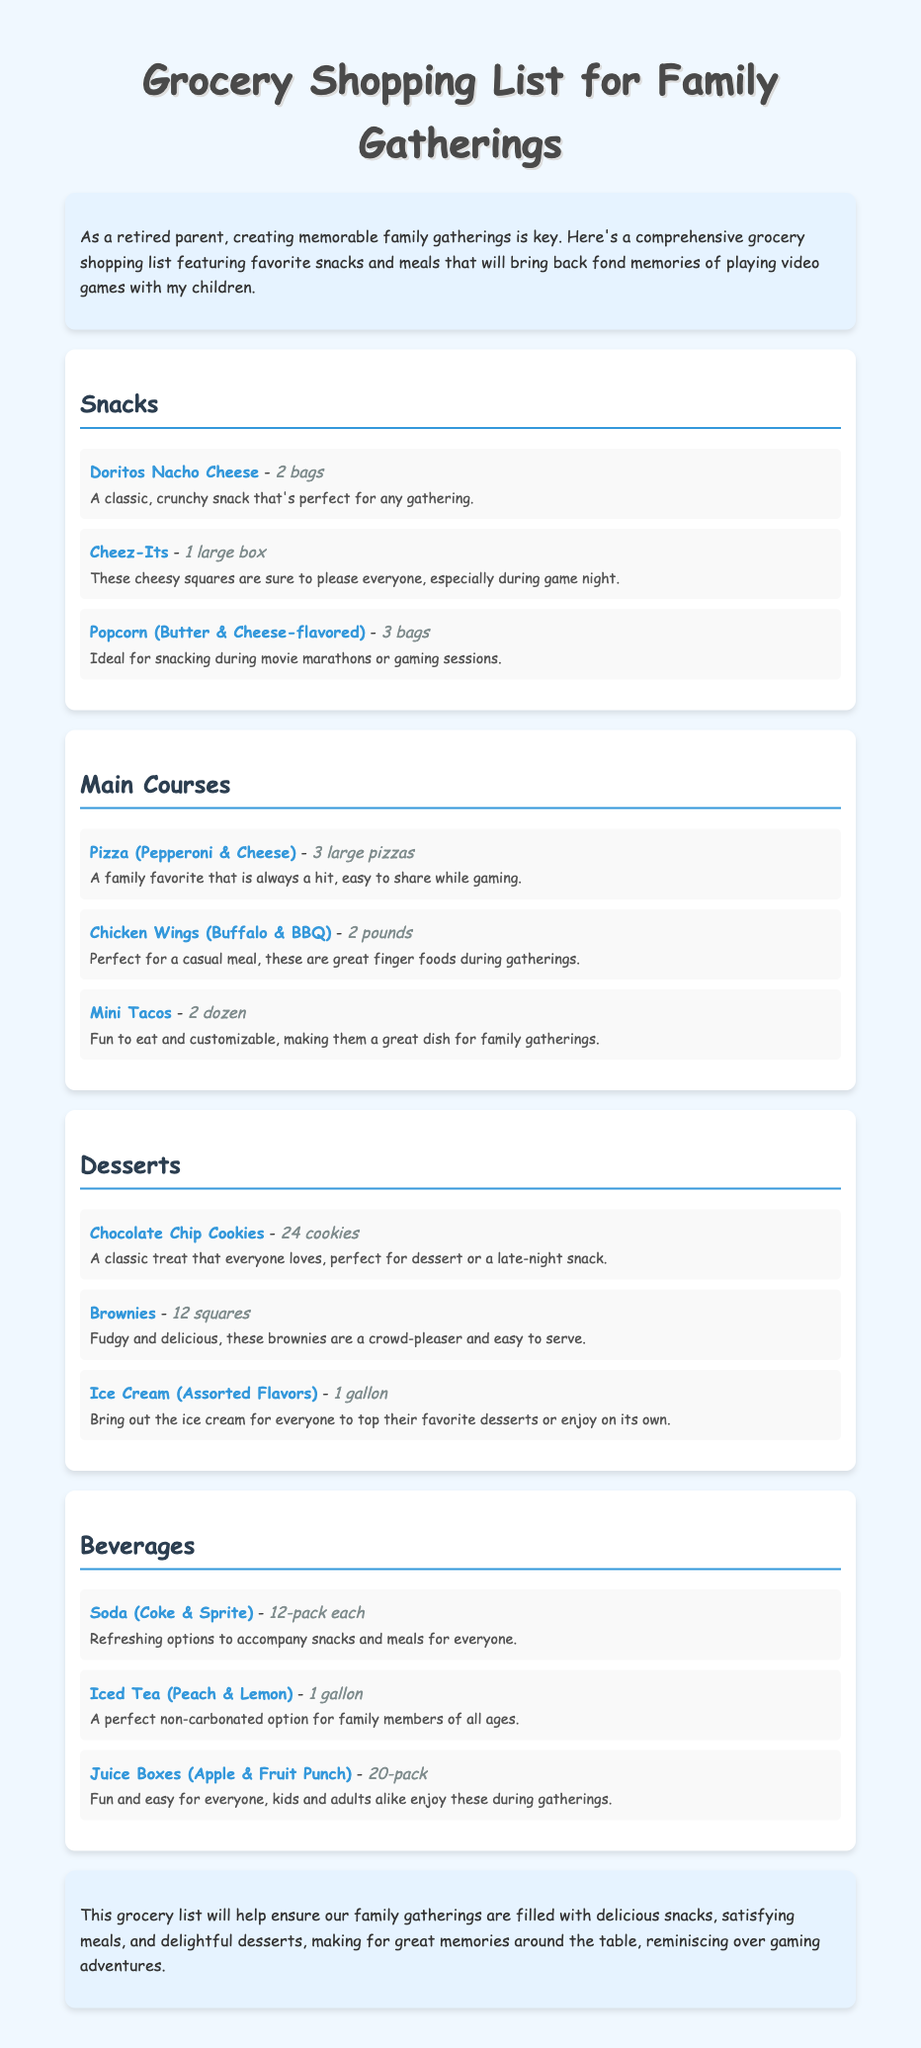What is the title of the document? The title appears at the top of the document and identifies the main theme regarding grocery shopping.
Answer: Grocery Shopping List for Family Gatherings How many bags of Doritos Nacho Cheese are listed? The document specifies the quantity of Doritos Nacho Cheese snacks under the Snacks section.
Answer: 2 bags What is a main course option mentioned that is customizable? The document provides details about the main course options, specifically highlighting an item that allows for customization.
Answer: Mini Tacos How many cookies are included in the dessert section? The document specifies the quantity of chocolate chip cookies listed as a dessert option.
Answer: 24 cookies What type of beverages are included alongside soda? The document lists various beverages, indicating a non-carbonated option available for family gatherings.
Answer: Iced Tea (Peach & Lemon) What description is given for the Chicken Wings? The document includes a specific description of the Chicken Wings dish in the main courses section.
Answer: Perfect for a casual meal, these are great finger foods during gatherings How many pounds of Chicken Wings are mentioned? The document provides a quantity for the Chicken Wings under the main courses section.
Answer: 2 pounds What is the purpose of the grocery shopping list? The introduction section outlines the intent behind creating this grocery shopping list for family gatherings.
Answer: To create memorable family gatherings 